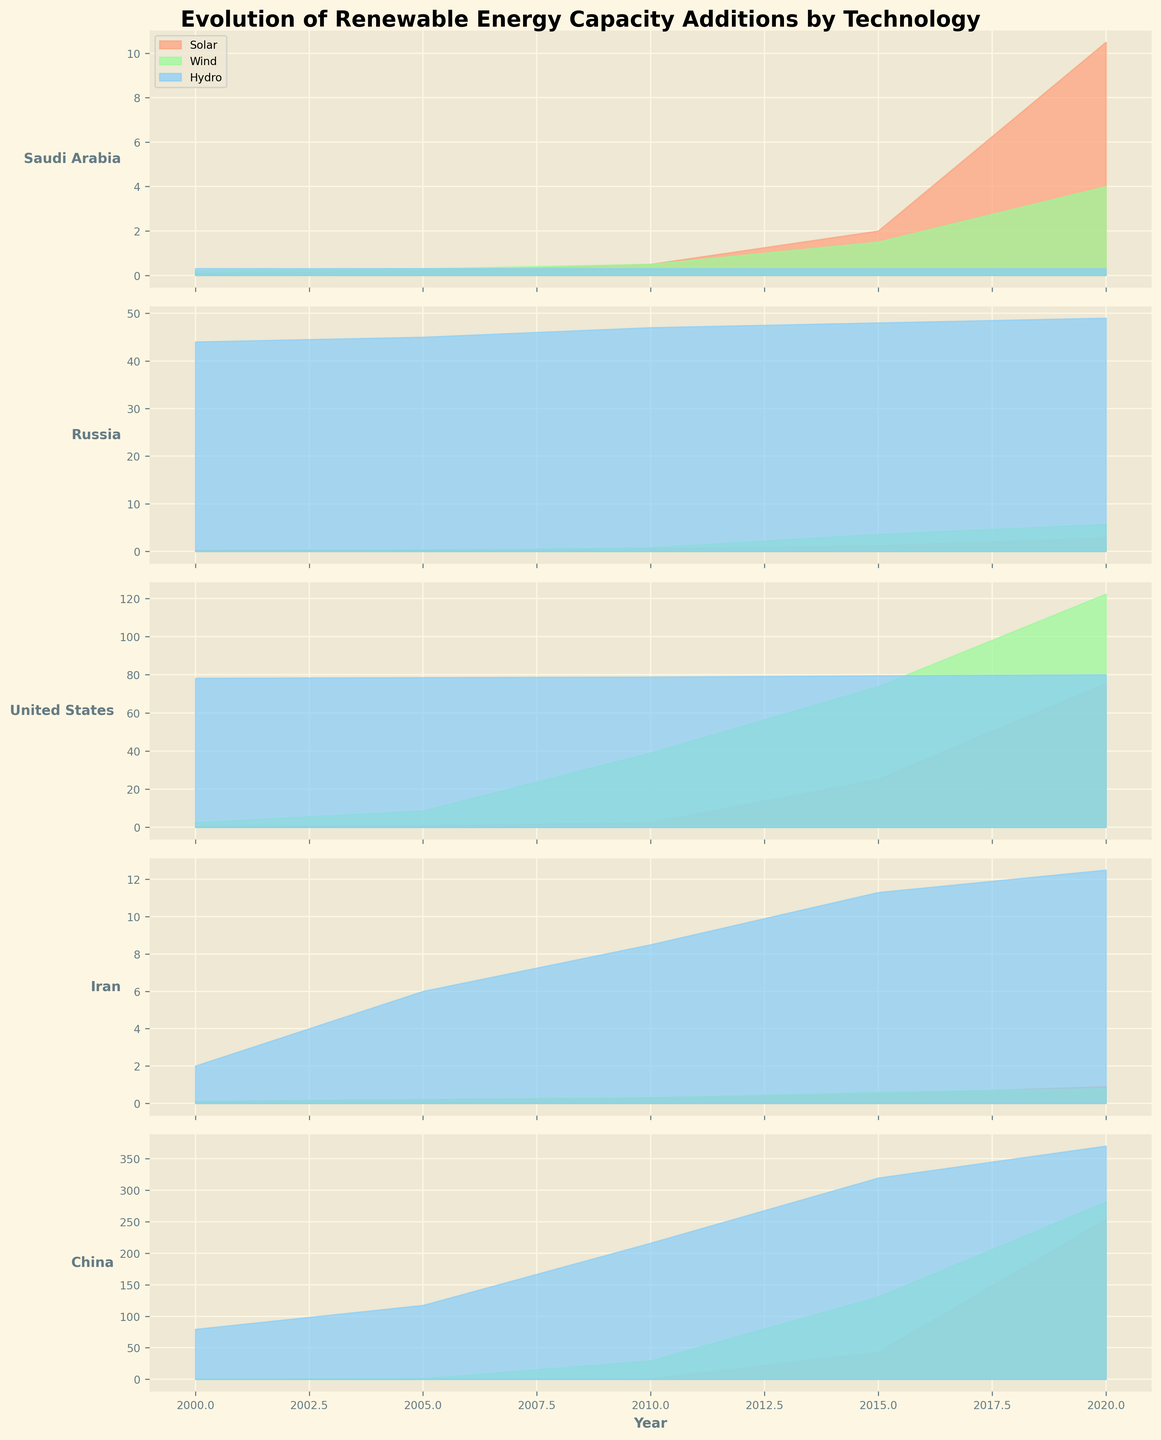What is the title of the figure? The title is located at the top of the figure, stating the overall subject of the plot.
Answer: Evolution of Renewable Energy Capacity Additions by Technology Which country shows the highest solar capacity addition in 2020? By comparing the levels of solar capacity addition across different countries for the year 2020, it is evident that China has the highest value.
Answer: China How did wind capacity addition in Russia change from 2000 to 2020? Track the wind capacity addition values for Russia from 2000 to 2020, which are 0.1, 0.2, 0.8, 3.6, and 5.7 respectively, indicating a steady increase.
Answer: Increased In which year did the United States have the most significant increase in solar capacity compared to the previous year shown on the plot? Comparing solar capacity from 2000 to 2005, 2005 to 2010, 2010 to 2015, and 2015 to 2020 for the United States, the biggest jump is between 2015 and 2020 (from 25.2 to 75.6).
Answer: 2020 What trend is observed for hydro capacity addition in Iran over the years? Observing the hydro bar heights for Iran, the values in each year (2.0, 6.0, 8.5, 11.3, 12.5) suggest a gradual increase in hydro capacity addition over the years.
Answer: Gradual increase Which country had the most balanced addition across all three technologies in 2010? Look for similar heights of the bars across all three technologies for each country in 2010. The United States has relatively balanced values in solar (2.5), wind (39.1), and hydro (78.8).
Answer: United States Does China or Saudi Arabia have a larger increase in solar capacity between 2015 and 2020? Calculate the increase for China (253.8 - 43.2 = 210.6) and Saudi Arabia (10.5 - 2 = 8.5). China has the larger increase.
Answer: China Which technology showed the least growth in Saudi Arabia from 2000 to 2020? Compare growth for solar, wind, and hydro in Saudi Arabia between 2000 and 2020. Hydro remains constant at 0.3 across all years.
Answer: Hydro In the year 2015, which country had the highest capacity addition in wind technology? Observe the height of the bars representing wind technology in 2015, where China exhibits the highest addition (131.0).
Answer: China By comparing the solar capacity in 2010, which country had more: Russia or Iran? Compare the values for solar capacity addition in 2010 for Russia (0.5) and Iran (0.3), showing Russia had more.
Answer: Russia 